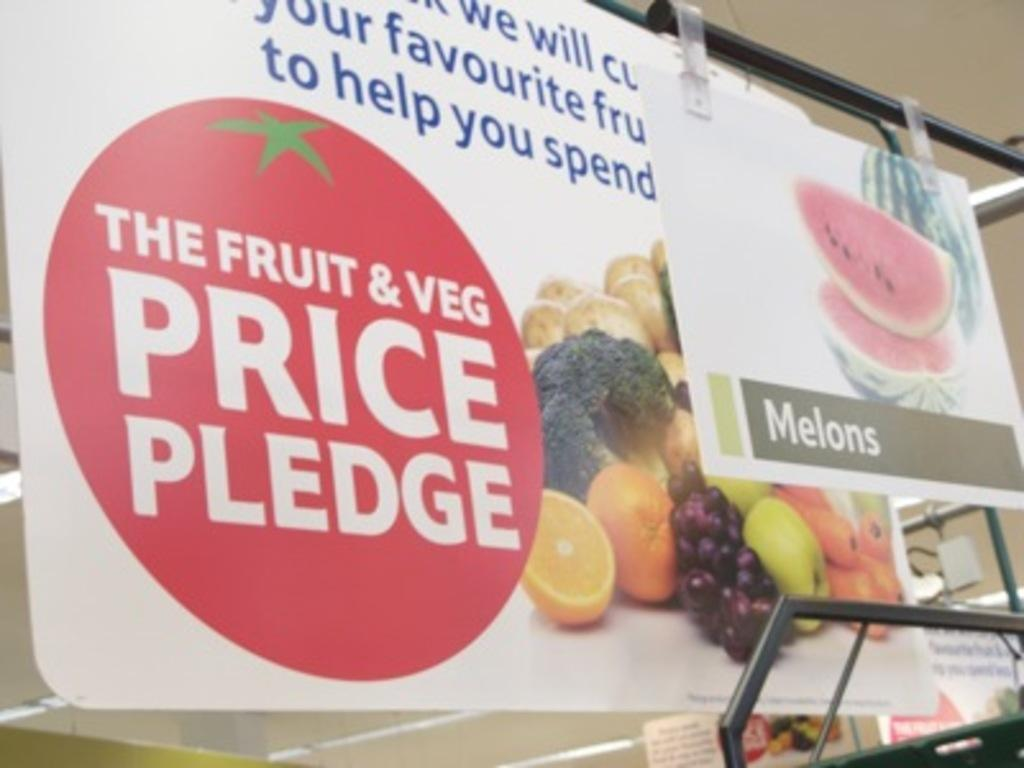What is the main object in the center of the image? There is a board in the center of the image. What can be found on the board? There is text and fruits depicted on the board. What can be seen in the background of the image? There are poles visible in the background of the image, and there might be a wall. What type of rings can be seen on the fruits in the image? There are no rings visible on the fruits in the image. What kind of noise can be heard coming from the market in the image? There is no market present in the image, so it's not possible to determine what kind of noise might be heard. 